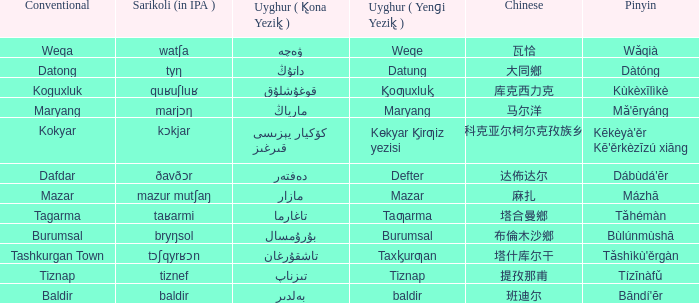Name the pinyin for mazar Mázhā. 